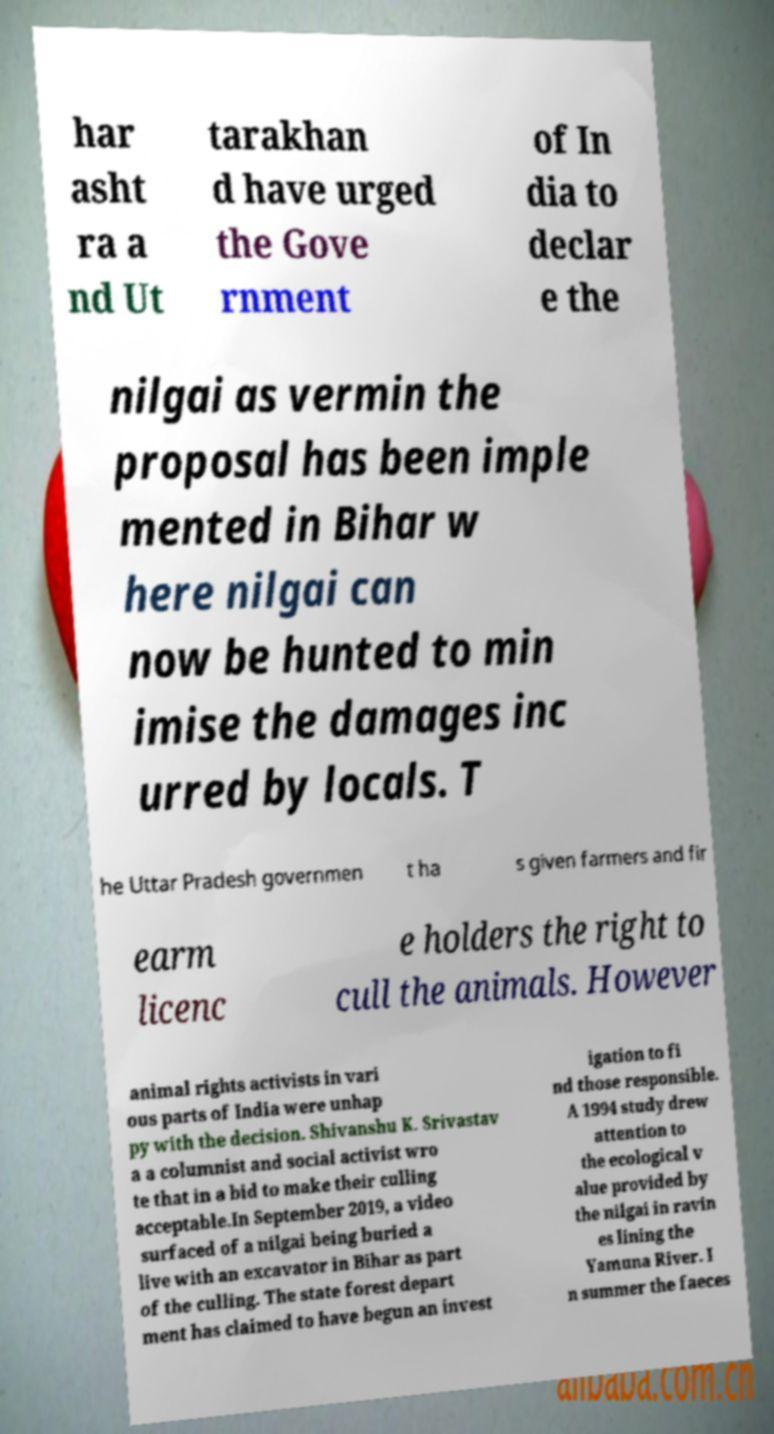Could you extract and type out the text from this image? har asht ra a nd Ut tarakhan d have urged the Gove rnment of In dia to declar e the nilgai as vermin the proposal has been imple mented in Bihar w here nilgai can now be hunted to min imise the damages inc urred by locals. T he Uttar Pradesh governmen t ha s given farmers and fir earm licenc e holders the right to cull the animals. However animal rights activists in vari ous parts of India were unhap py with the decision. Shivanshu K. Srivastav a a columnist and social activist wro te that in a bid to make their culling acceptable.In September 2019, a video surfaced of a nilgai being buried a live with an excavator in Bihar as part of the culling. The state forest depart ment has claimed to have begun an invest igation to fi nd those responsible. A 1994 study drew attention to the ecological v alue provided by the nilgai in ravin es lining the Yamuna River. I n summer the faeces 